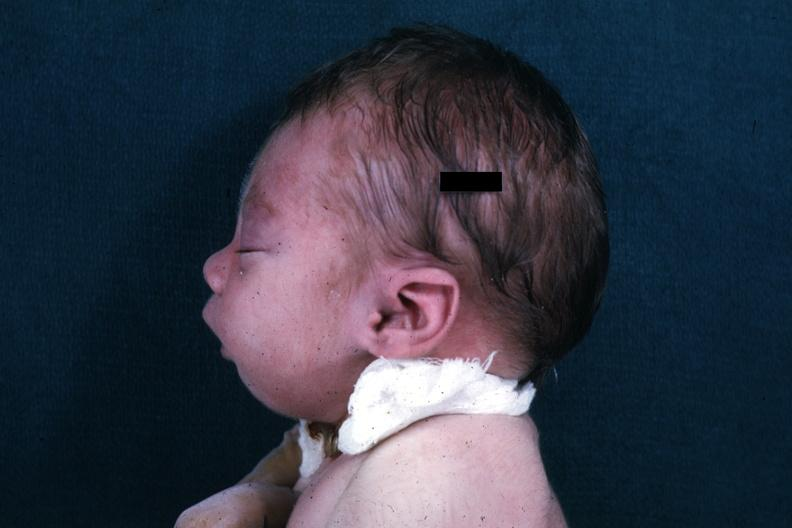what is present?
Answer the question using a single word or phrase. Pierre robin sndrome 